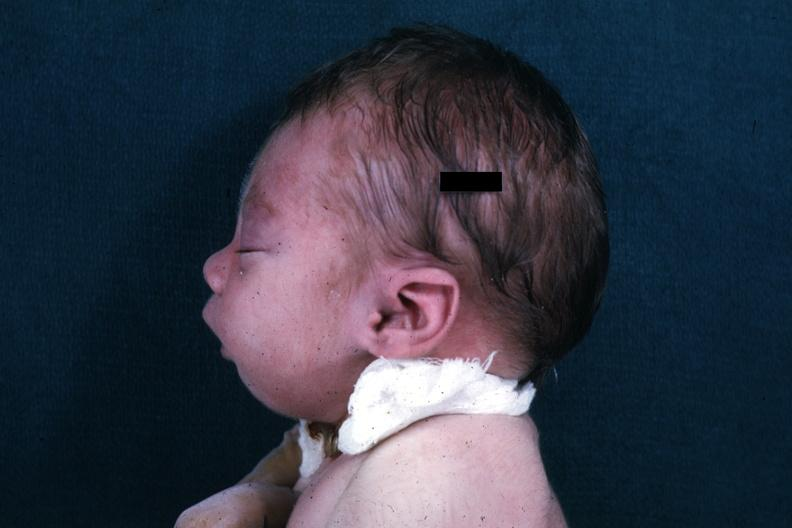what is present?
Answer the question using a single word or phrase. Pierre robin sndrome 